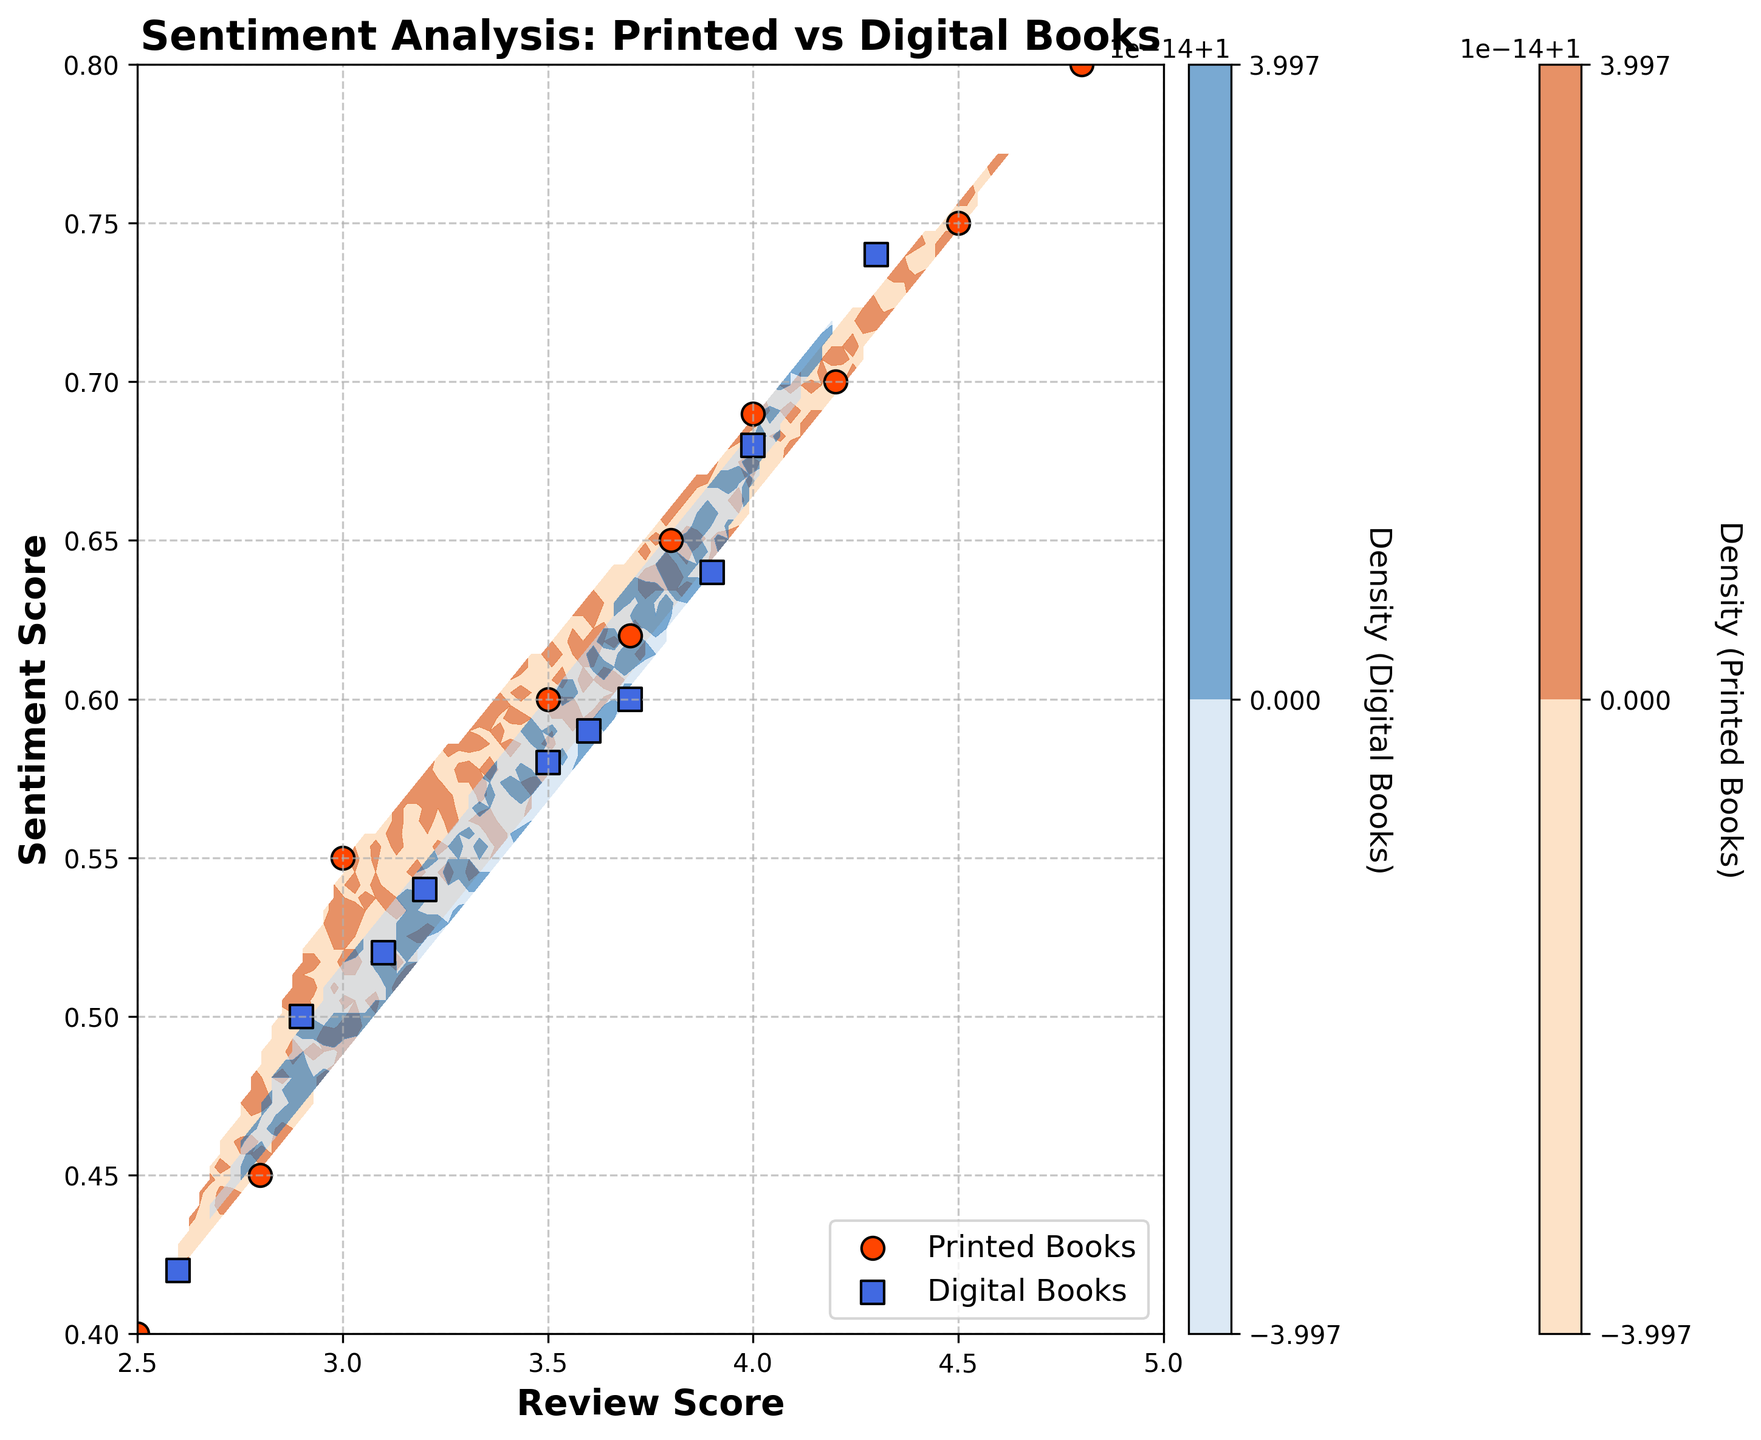1. What are the book types compared in the plot? The figure contains two distinct legend markers indicating the book types being compared. They are labeled "Printed Books" and "Digital Books".
Answer: Printed Books, Digital Books 2. Which axis represents the 'Review Score'? Observing the figure, the x-axis is labeled 'Review Score', indicating it represents review scores.
Answer: x-axis 3. What is the range of the 'Sentiment Score' on this plot? Checking the y-axis, 'Sentiment Score' ranges from 0.4 to 0.8.
Answer: 0.4 to 0.8 4. How many distinct colors are used in the contour plot and what do they represent? Two distinct colors can be seen in the contour plot: oranges representing Printed Books and blues representing Digital Books.
Answer: Two, orange and blue 5. What is the relationship between the density of data points for Printed Books and Digital Books based on the color intensity? The color intensities, orange for Printed Books and blue for Digital Books, indicate density of data points, with darker shades representing higher densities.
Answer: Darker color indicates higher density 6. Which book type shows a higher concentration of reviews with Sentiment Scores between 0.6 and 0.7? Analyzing the contours, Printed Books (orange areas) show a higher concentration of reviews in the 0.6 to 0.7 sentiment score range compared to Digital Books.
Answer: Printed Books 7. Compare the overall distribution of sentiment scores between Printed Books and Digital Books. Observing the scatter plot and contour shades, Printed Books' sentiment scores range from approximately 0.4 to 0.8, whereas Digital Books' sentiment scores show a similar range but with a slightly different pattern of concentration.
Answer: Both have a similar range, different concentration patterns 8. What is the sentiment score of the lowest-rated Printed Book in the dataset? By locating the lowest review score for Printed Books, we find the corresponding sentiment score is about 0.4.
Answer: About 0.4 9. Are there any clusters of review scores noticeable for Digital Books? Observing the scatter points within the contour of Digital Books, clusters appear around review scores of 3.5 to 4.0.
Answer: Around 3.5 to 4.0 10. Which book type shows a greater spread in review scores, and how can you tell? By analyzing the spread of scatter points, Printed Books review scores range broadly from 2.5 to 4.8 compared to Digital Books which cluster more closely between 2.6 to 4.3.
Answer: Printed Books 